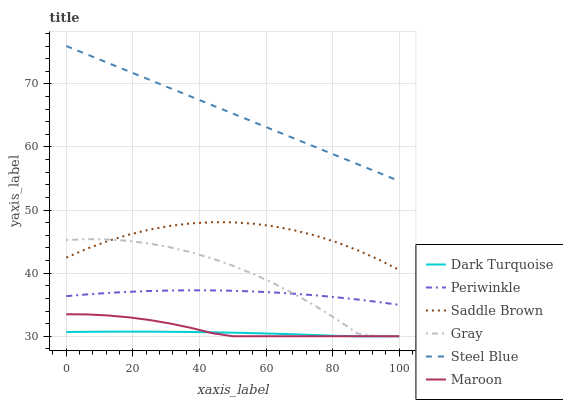Does Steel Blue have the minimum area under the curve?
Answer yes or no. No. Does Dark Turquoise have the maximum area under the curve?
Answer yes or no. No. Is Dark Turquoise the smoothest?
Answer yes or no. No. Is Dark Turquoise the roughest?
Answer yes or no. No. Does Steel Blue have the lowest value?
Answer yes or no. No. Does Dark Turquoise have the highest value?
Answer yes or no. No. Is Dark Turquoise less than Steel Blue?
Answer yes or no. Yes. Is Periwinkle greater than Dark Turquoise?
Answer yes or no. Yes. Does Dark Turquoise intersect Steel Blue?
Answer yes or no. No. 